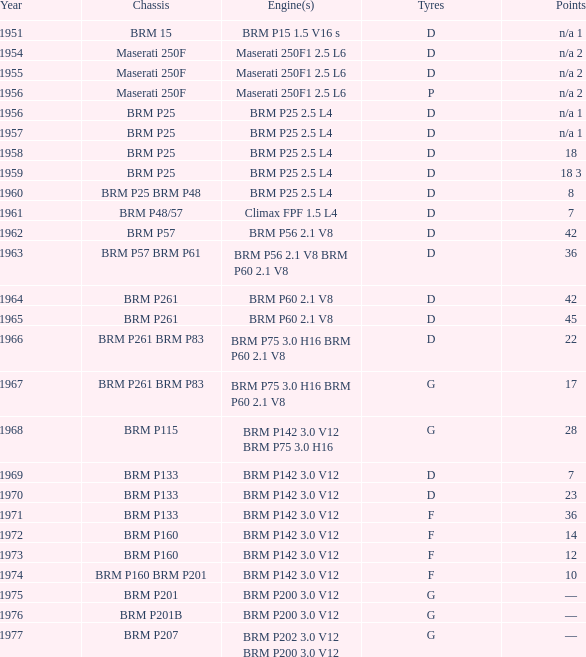Determine the combined years of brm p202 1977.0. I'm looking to parse the entire table for insights. Could you assist me with that? {'header': ['Year', 'Chassis', 'Engine(s)', 'Tyres', 'Points'], 'rows': [['1951', 'BRM 15', 'BRM P15 1.5 V16 s', 'D', 'n/a 1'], ['1954', 'Maserati 250F', 'Maserati 250F1 2.5 L6', 'D', 'n/a 2'], ['1955', 'Maserati 250F', 'Maserati 250F1 2.5 L6', 'D', 'n/a 2'], ['1956', 'Maserati 250F', 'Maserati 250F1 2.5 L6', 'P', 'n/a 2'], ['1956', 'BRM P25', 'BRM P25 2.5 L4', 'D', 'n/a 1'], ['1957', 'BRM P25', 'BRM P25 2.5 L4', 'D', 'n/a 1'], ['1958', 'BRM P25', 'BRM P25 2.5 L4', 'D', '18'], ['1959', 'BRM P25', 'BRM P25 2.5 L4', 'D', '18 3'], ['1960', 'BRM P25 BRM P48', 'BRM P25 2.5 L4', 'D', '8'], ['1961', 'BRM P48/57', 'Climax FPF 1.5 L4', 'D', '7'], ['1962', 'BRM P57', 'BRM P56 2.1 V8', 'D', '42'], ['1963', 'BRM P57 BRM P61', 'BRM P56 2.1 V8 BRM P60 2.1 V8', 'D', '36'], ['1964', 'BRM P261', 'BRM P60 2.1 V8', 'D', '42'], ['1965', 'BRM P261', 'BRM P60 2.1 V8', 'D', '45'], ['1966', 'BRM P261 BRM P83', 'BRM P75 3.0 H16 BRM P60 2.1 V8', 'D', '22'], ['1967', 'BRM P261 BRM P83', 'BRM P75 3.0 H16 BRM P60 2.1 V8', 'G', '17'], ['1968', 'BRM P115', 'BRM P142 3.0 V12 BRM P75 3.0 H16', 'G', '28'], ['1969', 'BRM P133', 'BRM P142 3.0 V12', 'D', '7'], ['1970', 'BRM P133', 'BRM P142 3.0 V12', 'D', '23'], ['1971', 'BRM P133', 'BRM P142 3.0 V12', 'F', '36'], ['1972', 'BRM P160', 'BRM P142 3.0 V12', 'F', '14'], ['1973', 'BRM P160', 'BRM P142 3.0 V12', 'F', '12'], ['1974', 'BRM P160 BRM P201', 'BRM P142 3.0 V12', 'F', '10'], ['1975', 'BRM P201', 'BRM P200 3.0 V12', 'G', '—'], ['1976', 'BRM P201B', 'BRM P200 3.0 V12', 'G', '—'], ['1977', 'BRM P207', 'BRM P202 3.0 V12 BRM P200 3.0 V12', 'G', '—']]} 